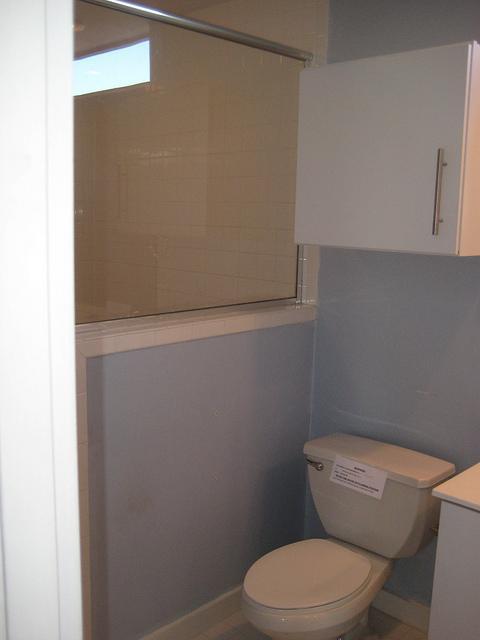How many people are holding onto the handlebar of the motorcycle?
Give a very brief answer. 0. 